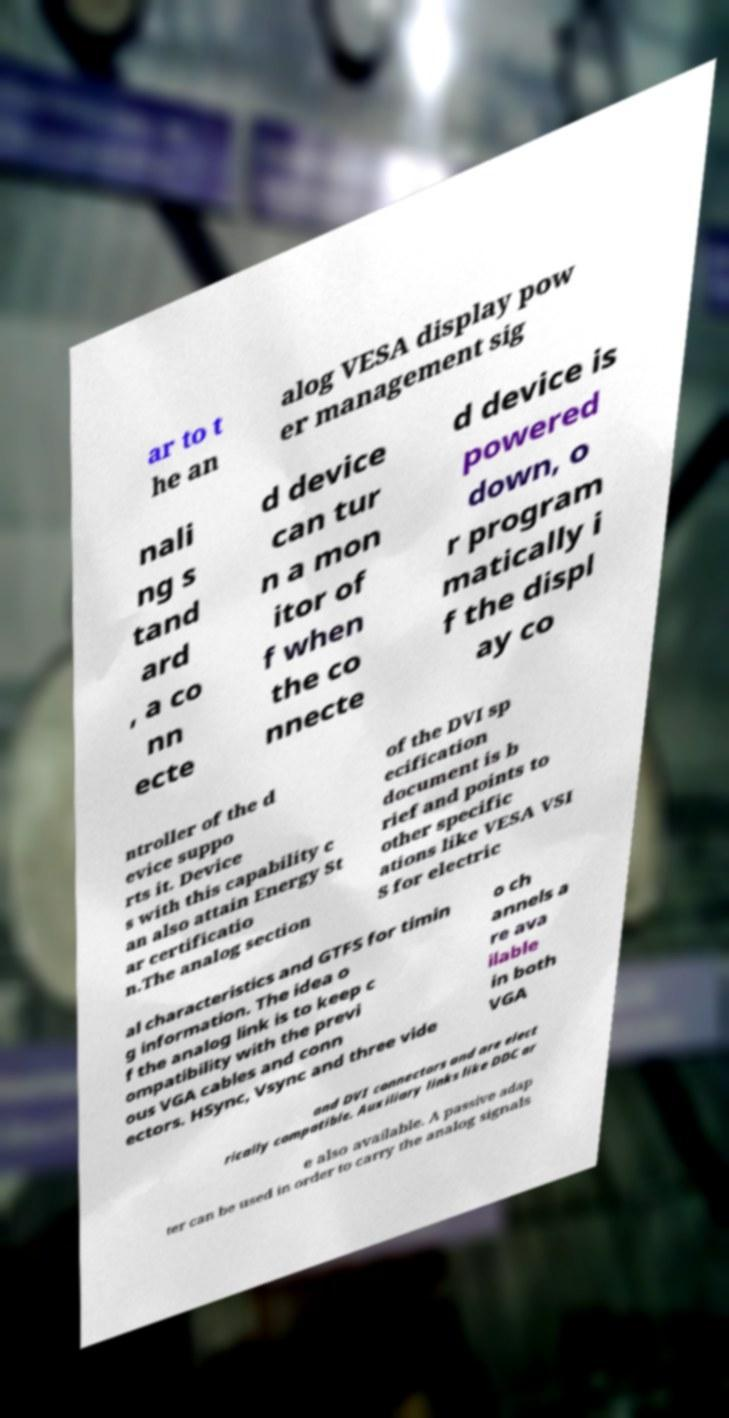Could you assist in decoding the text presented in this image and type it out clearly? ar to t he an alog VESA display pow er management sig nali ng s tand ard , a co nn ecte d device can tur n a mon itor of f when the co nnecte d device is powered down, o r program matically i f the displ ay co ntroller of the d evice suppo rts it. Device s with this capability c an also attain Energy St ar certificatio n.The analog section of the DVI sp ecification document is b rief and points to other specific ations like VESA VSI S for electric al characteristics and GTFS for timin g information. The idea o f the analog link is to keep c ompatibility with the previ ous VGA cables and conn ectors. HSync, Vsync and three vide o ch annels a re ava ilable in both VGA and DVI connectors and are elect rically compatible. Auxiliary links like DDC ar e also available. A passive adap ter can be used in order to carry the analog signals 